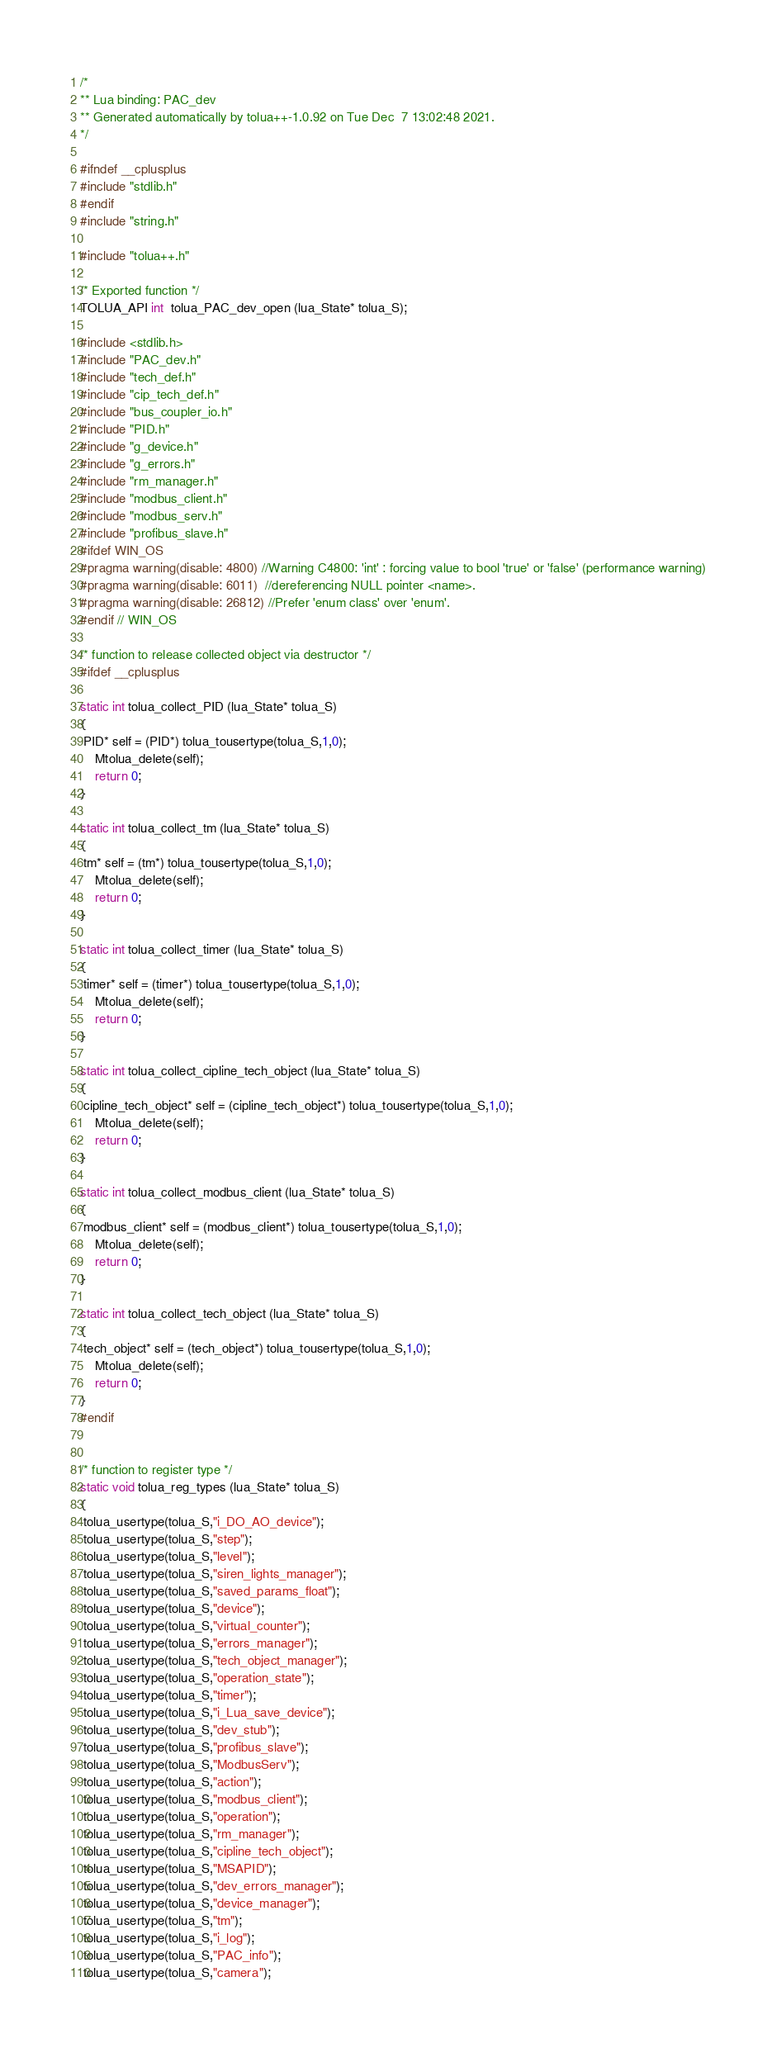<code> <loc_0><loc_0><loc_500><loc_500><_C++_>/*
** Lua binding: PAC_dev
** Generated automatically by tolua++-1.0.92 on Tue Dec  7 13:02:48 2021.
*/

#ifndef __cplusplus
#include "stdlib.h"
#endif
#include "string.h"

#include "tolua++.h"

/* Exported function */
TOLUA_API int  tolua_PAC_dev_open (lua_State* tolua_S);

#include <stdlib.h>
#include "PAC_dev.h"
#include "tech_def.h"
#include "cip_tech_def.h"
#include "bus_coupler_io.h"
#include "PID.h"
#include "g_device.h"
#include "g_errors.h"
#include "rm_manager.h"
#include "modbus_client.h"
#include "modbus_serv.h"
#include "profibus_slave.h"
#ifdef WIN_OS
#pragma warning(disable: 4800) //Warning C4800: 'int' : forcing value to bool 'true' or 'false' (performance warning)
#pragma warning(disable: 6011)  //dereferencing NULL pointer <name>.
#pragma warning(disable: 26812) //Prefer 'enum class' over 'enum'.
#endif // WIN_OS

/* function to release collected object via destructor */
#ifdef __cplusplus

static int tolua_collect_PID (lua_State* tolua_S)
{
 PID* self = (PID*) tolua_tousertype(tolua_S,1,0);
	Mtolua_delete(self);
	return 0;
}

static int tolua_collect_tm (lua_State* tolua_S)
{
 tm* self = (tm*) tolua_tousertype(tolua_S,1,0);
	Mtolua_delete(self);
	return 0;
}

static int tolua_collect_timer (lua_State* tolua_S)
{
 timer* self = (timer*) tolua_tousertype(tolua_S,1,0);
	Mtolua_delete(self);
	return 0;
}

static int tolua_collect_cipline_tech_object (lua_State* tolua_S)
{
 cipline_tech_object* self = (cipline_tech_object*) tolua_tousertype(tolua_S,1,0);
	Mtolua_delete(self);
	return 0;
}

static int tolua_collect_modbus_client (lua_State* tolua_S)
{
 modbus_client* self = (modbus_client*) tolua_tousertype(tolua_S,1,0);
	Mtolua_delete(self);
	return 0;
}

static int tolua_collect_tech_object (lua_State* tolua_S)
{
 tech_object* self = (tech_object*) tolua_tousertype(tolua_S,1,0);
	Mtolua_delete(self);
	return 0;
}
#endif


/* function to register type */
static void tolua_reg_types (lua_State* tolua_S)
{
 tolua_usertype(tolua_S,"i_DO_AO_device");
 tolua_usertype(tolua_S,"step");
 tolua_usertype(tolua_S,"level");
 tolua_usertype(tolua_S,"siren_lights_manager");
 tolua_usertype(tolua_S,"saved_params_float");
 tolua_usertype(tolua_S,"device");
 tolua_usertype(tolua_S,"virtual_counter");
 tolua_usertype(tolua_S,"errors_manager");
 tolua_usertype(tolua_S,"tech_object_manager");
 tolua_usertype(tolua_S,"operation_state");
 tolua_usertype(tolua_S,"timer");
 tolua_usertype(tolua_S,"i_Lua_save_device");
 tolua_usertype(tolua_S,"dev_stub");
 tolua_usertype(tolua_S,"profibus_slave");
 tolua_usertype(tolua_S,"ModbusServ");
 tolua_usertype(tolua_S,"action");
 tolua_usertype(tolua_S,"modbus_client");
 tolua_usertype(tolua_S,"operation");
 tolua_usertype(tolua_S,"rm_manager");
 tolua_usertype(tolua_S,"cipline_tech_object");
 tolua_usertype(tolua_S,"MSAPID");
 tolua_usertype(tolua_S,"dev_errors_manager");
 tolua_usertype(tolua_S,"device_manager");
 tolua_usertype(tolua_S,"tm");
 tolua_usertype(tolua_S,"i_log");
 tolua_usertype(tolua_S,"PAC_info");
 tolua_usertype(tolua_S,"camera");</code> 